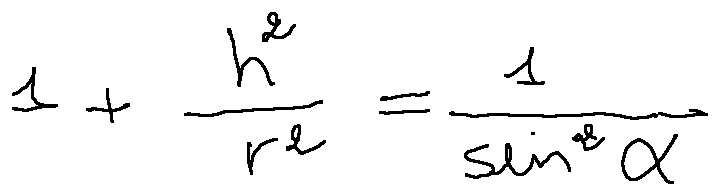Convert formula to latex. <formula><loc_0><loc_0><loc_500><loc_500>1 + \frac { h ^ { 2 } } { r ^ { 2 } } = \frac { 1 } { \sin ^ { 2 } \alpha }</formula> 